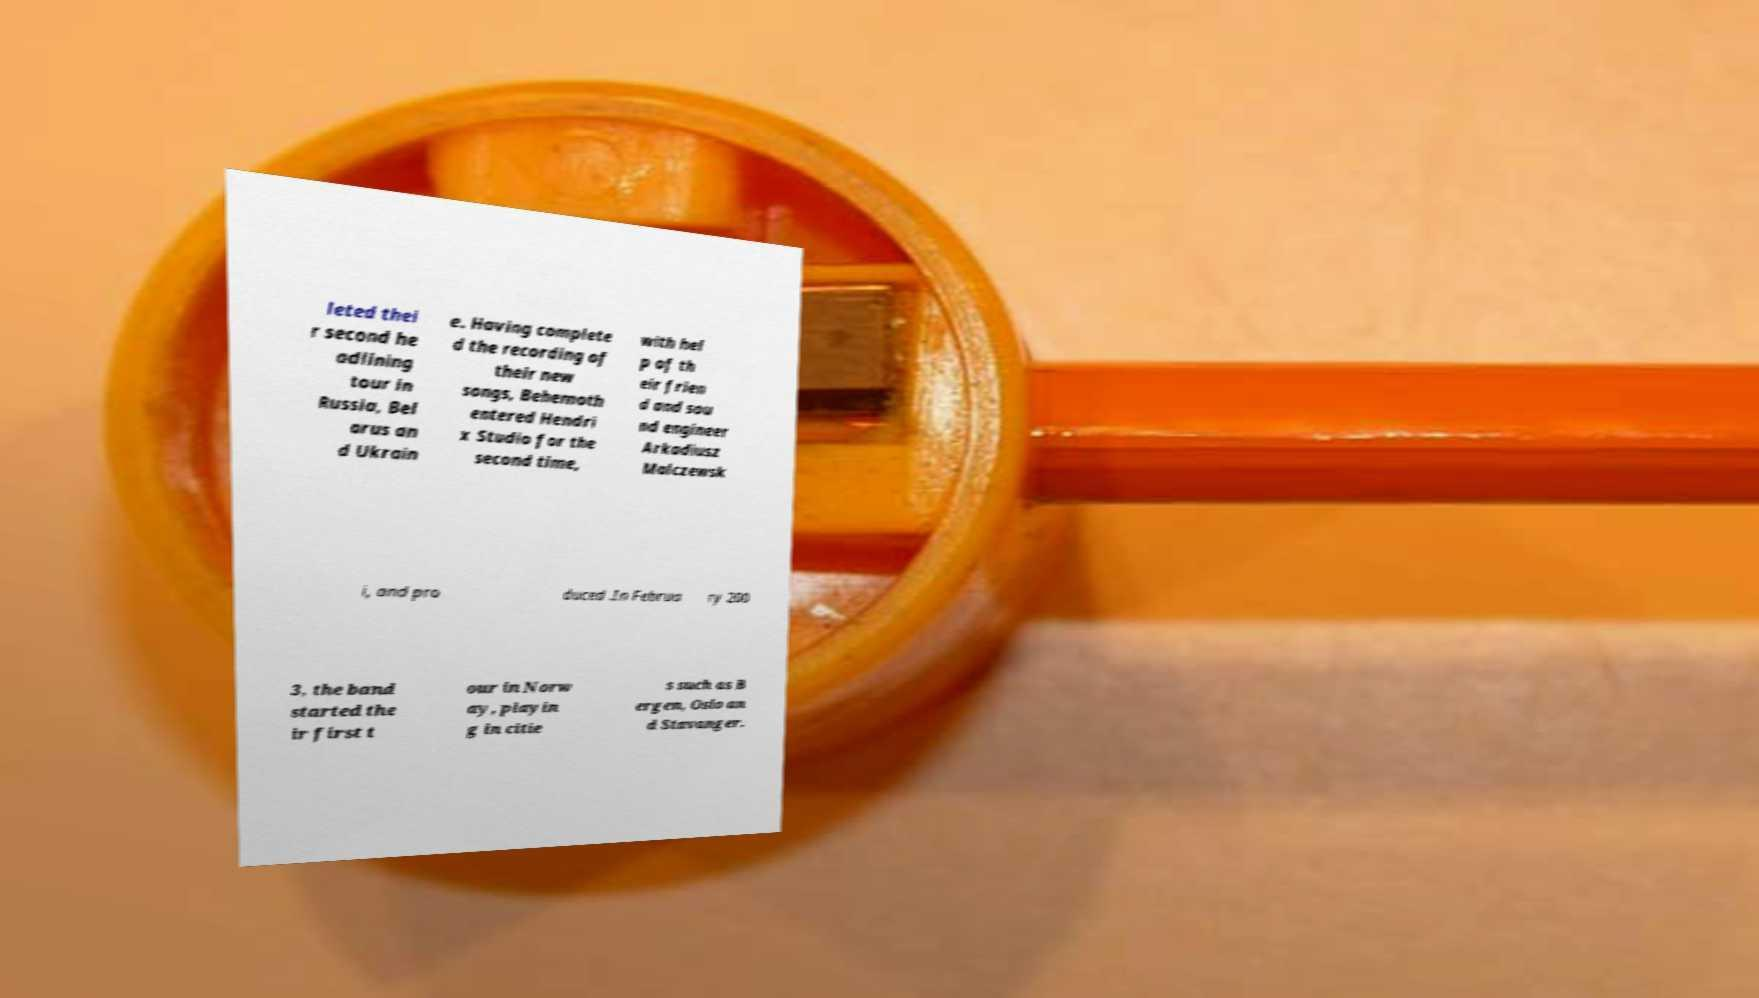For documentation purposes, I need the text within this image transcribed. Could you provide that? leted thei r second he adlining tour in Russia, Bel arus an d Ukrain e. Having complete d the recording of their new songs, Behemoth entered Hendri x Studio for the second time, with hel p of th eir frien d and sou nd engineer Arkadiusz Malczewsk i, and pro duced .In Februa ry 200 3, the band started the ir first t our in Norw ay, playin g in citie s such as B ergen, Oslo an d Stavanger. 